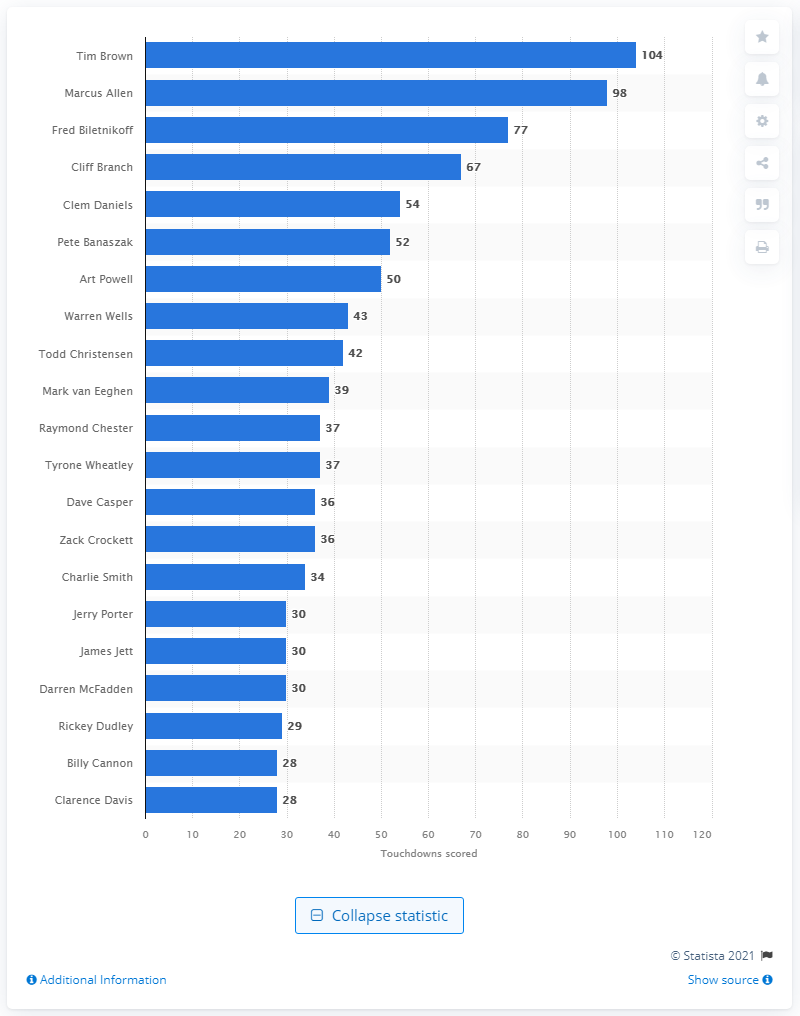Mention a couple of crucial points in this snapshot. The career touchdown leader of the Oakland/Las Vegas Raiders is Tim Brown. 